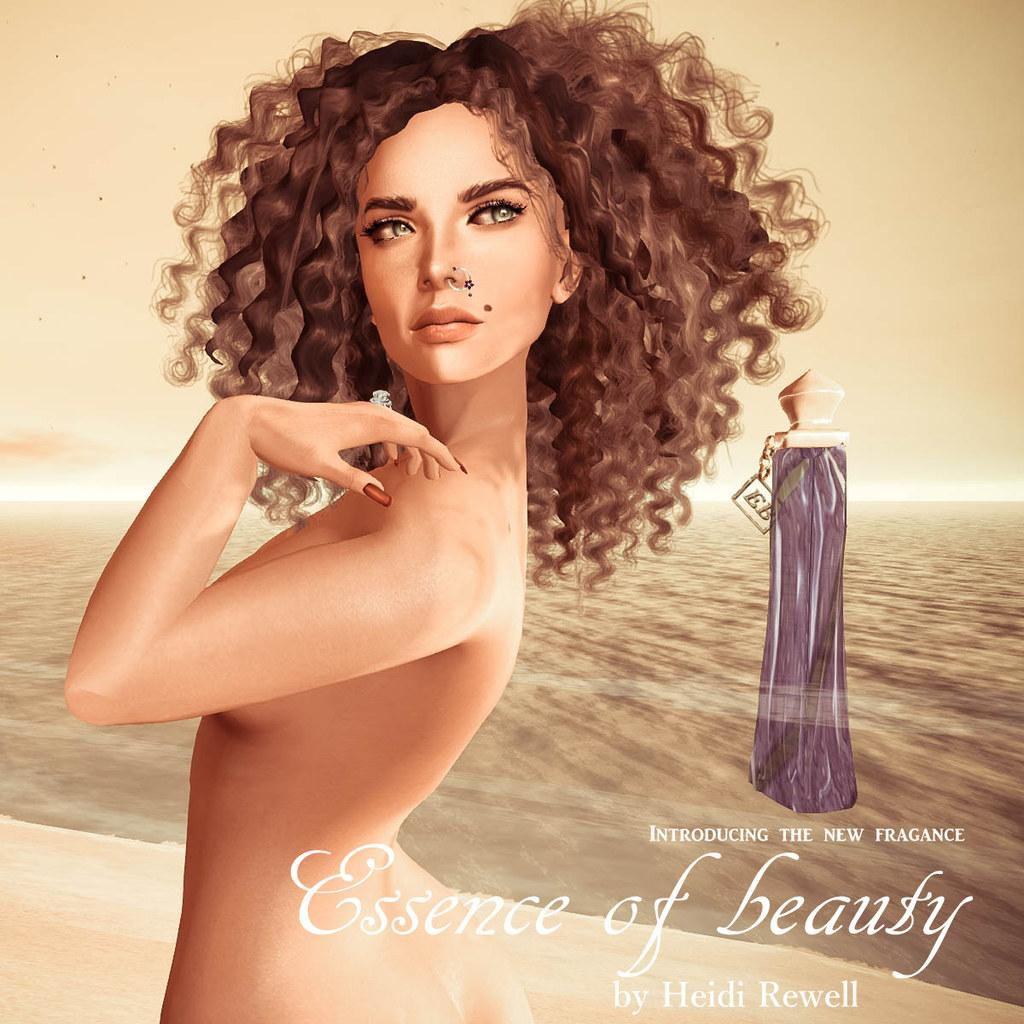<image>
Give a short and clear explanation of the subsequent image. Poster showing a woman posing and the words "Essence of Beauty". 